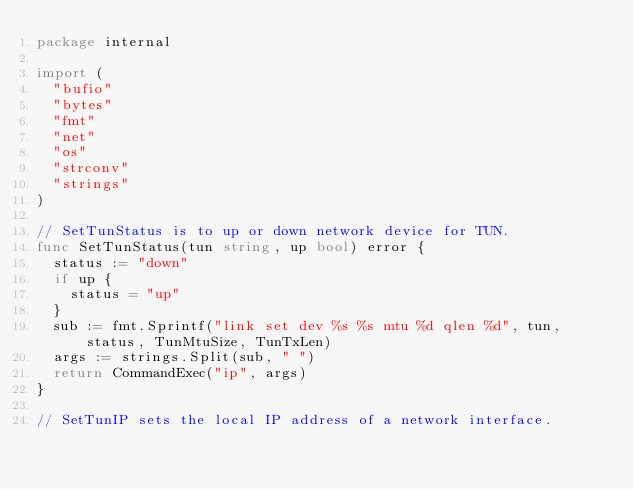<code> <loc_0><loc_0><loc_500><loc_500><_Go_>package internal

import (
	"bufio"
	"bytes"
	"fmt"
	"net"
	"os"
	"strconv"
	"strings"
)

// SetTunStatus is to up or down network device for TUN.
func SetTunStatus(tun string, up bool) error {
	status := "down"
	if up {
		status = "up"
	}
	sub := fmt.Sprintf("link set dev %s %s mtu %d qlen %d", tun, status, TunMtuSize, TunTxLen)
	args := strings.Split(sub, " ")
	return CommandExec("ip", args)
}

// SetTunIP sets the local IP address of a network interface.</code> 